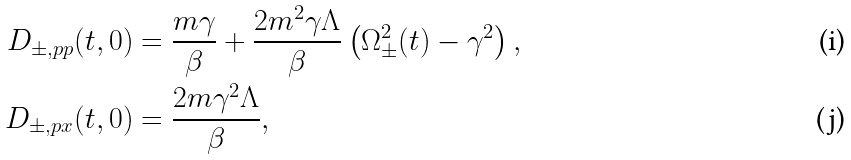Convert formula to latex. <formula><loc_0><loc_0><loc_500><loc_500>D _ { \pm , p p } ( t , 0 ) & = \frac { m \gamma } { \beta } + \frac { 2 m ^ { 2 } \gamma \Lambda } { \beta } \left ( \Omega _ { \pm } ^ { 2 } ( t ) - \gamma ^ { 2 } \right ) , \\ D _ { \pm , p x } ( t , 0 ) & = \frac { 2 m \gamma ^ { 2 } \Lambda } { \beta } ,</formula> 